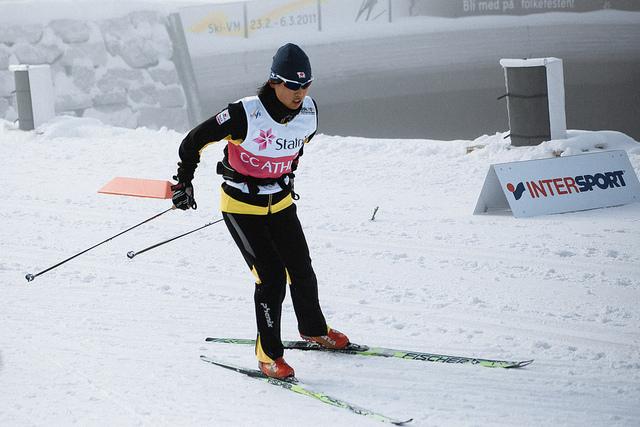Is this a summer picture?
Short answer required. No. Is the skier going downhill?
Short answer required. No. What is the weather like in this picture?
Answer briefly. Cold. Are they at a resort?
Keep it brief. Yes. 